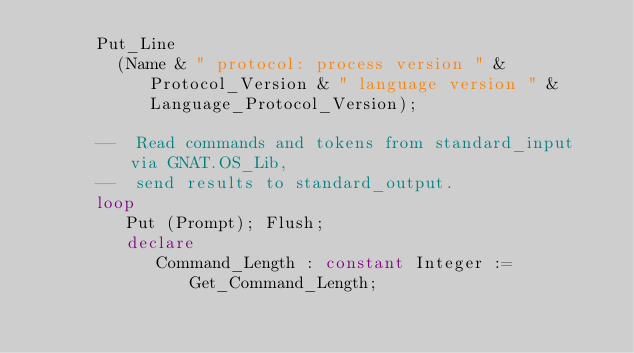Convert code to text. <code><loc_0><loc_0><loc_500><loc_500><_Ada_>      Put_Line
        (Name & " protocol: process version " & Protocol_Version & " language version " & Language_Protocol_Version);

      --  Read commands and tokens from standard_input via GNAT.OS_Lib,
      --  send results to standard_output.
      loop
         Put (Prompt); Flush;
         declare
            Command_Length : constant Integer := Get_Command_Length;</code> 